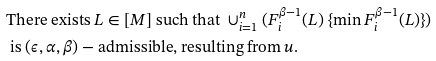Convert formula to latex. <formula><loc_0><loc_0><loc_500><loc_500>& \text {There exists } L \in [ M ] \text { such that } \cup _ { i = 1 } ^ { n } ( F _ { i } ^ { \beta - 1 } ( L ) \ \{ \min F _ { i } ^ { \beta - 1 } ( L ) \} ) \\ & \text { is } ( \epsilon , \alpha , \beta ) - \text {admissible, resulting from } u .</formula> 